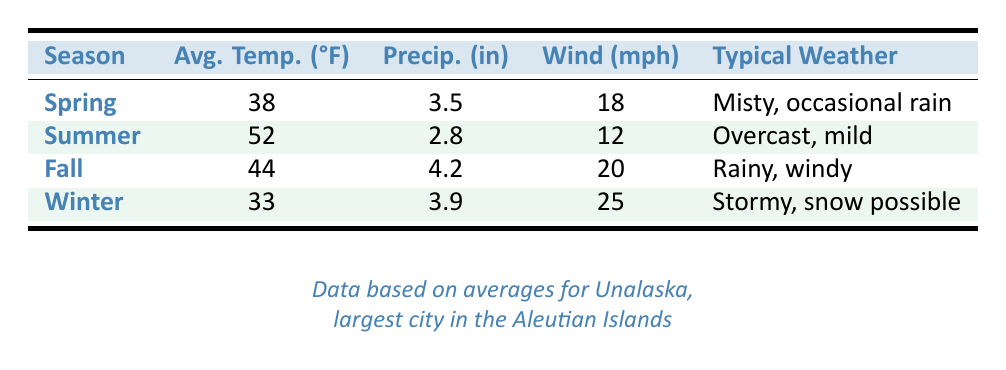What is the average temperature in Summer? The table shows that the average temperature in Summer is listed in the corresponding row under the "Avg. Temp. (°F)" column. It states the value as 52°F.
Answer: 52°F Which season has the highest wind speed? By comparing the values in the "Wind (mph)" column, Winter has the highest wind speed at 25 mph.
Answer: Winter Is it true that Fall has more precipitation than Spring? The precipitation values for Fall (4.2 inches) and Spring (3.5 inches) can be found in the table's respective rows. Since 4.2 is greater than 3.5, the statement is true.
Answer: Yes What is the total precipitation in Spring and Summer combined? To find the total precipitation for Spring and Summer, add the precipitation from both seasons: Spring (3.5 inches) + Summer (2.8 inches) = 6.3 inches.
Answer: 6.3 inches During which season are the temperatures the lowest? By examining the "Avg. Temp. (°F)" column, Winter has the lowest temperature at 33°F, which is less than all the other seasons.
Answer: Winter Is it true that the Summer season has the least precipitation? In the table, Summer has 2.8 inches of precipitation, while Spring has 3.5 inches, Fall has 4.2 inches, and Winter has 3.9 inches. Since Summer's value is the lowest among these, the statement is true.
Answer: Yes What is the average temperature difference between Fall and Winter? First, identify the average temperatures: Fall is 44°F while Winter is 33°F. The difference is calculated as Fall (44°F) - Winter (33°F) = 11°F.
Answer: 11°F In which season can we expect milder weather conditions? Summer is listed as "Overcast, mild" in typical weather conditions, which suggests it would be expected to be milder compared to the other seasons that are described more harshly, like Winter (stormy, snow possible).
Answer: Summer 